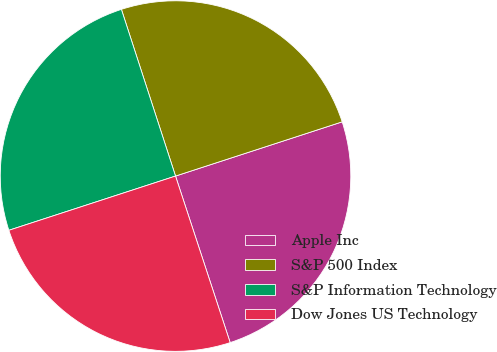Convert chart to OTSL. <chart><loc_0><loc_0><loc_500><loc_500><pie_chart><fcel>Apple Inc<fcel>S&P 500 Index<fcel>S&P Information Technology<fcel>Dow Jones US Technology<nl><fcel>24.96%<fcel>24.99%<fcel>25.01%<fcel>25.04%<nl></chart> 